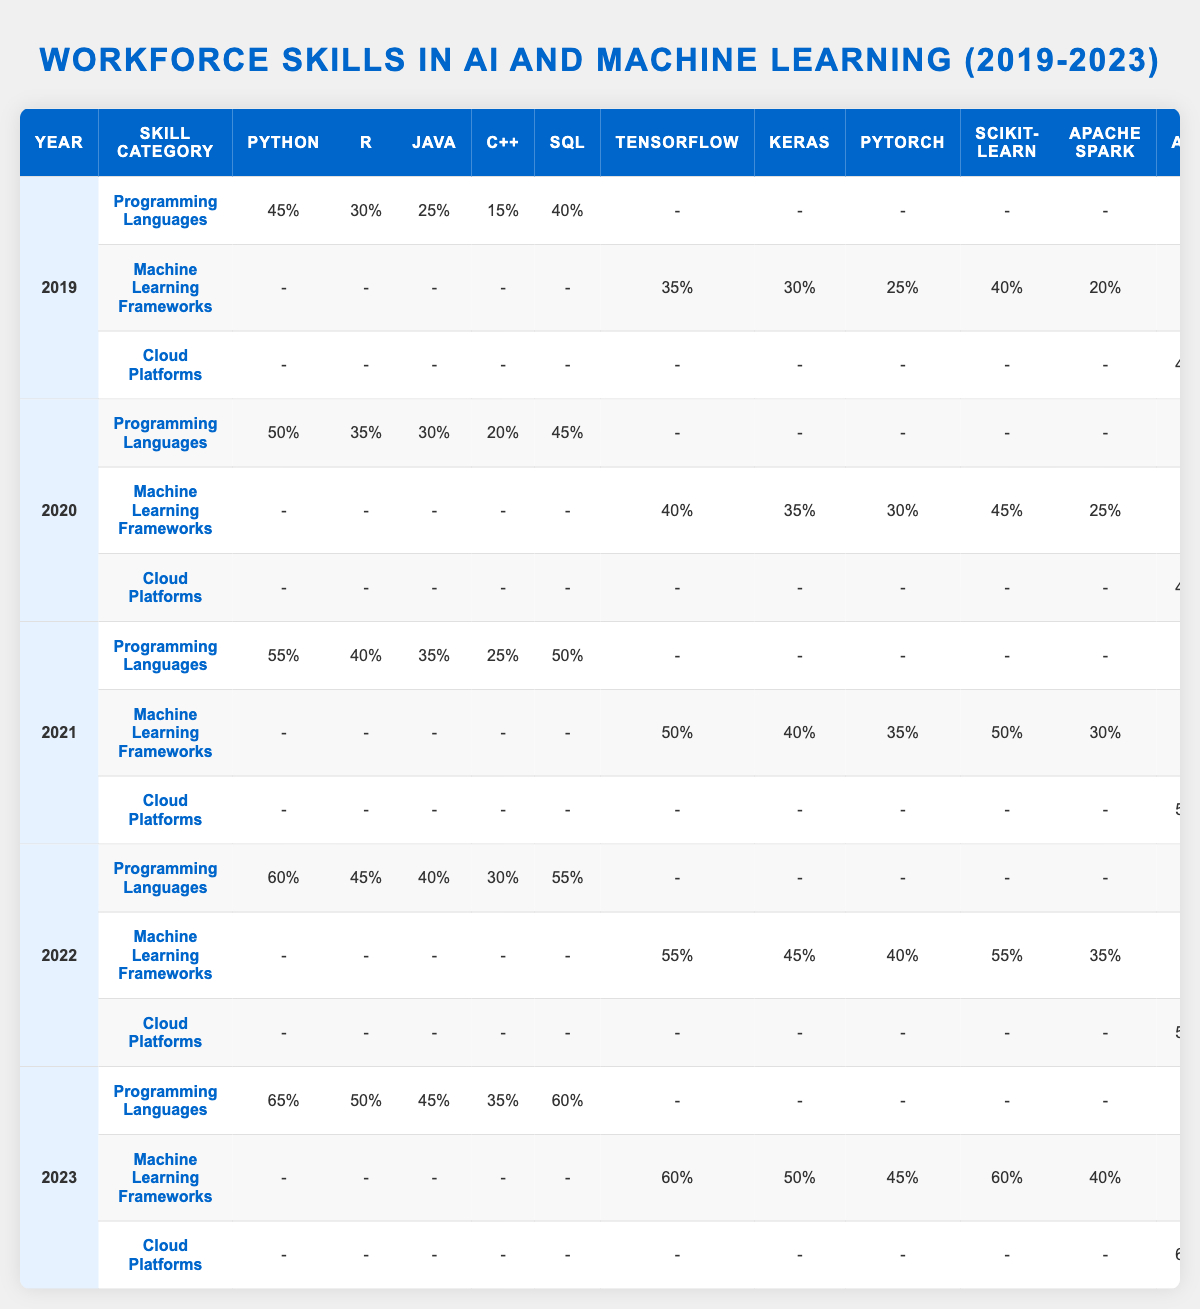What percentage of workforce skills in programming languages was attributed to Python in 2022? In 2022, the value for Python under the Programming Languages skill category is 60%.
Answer: 60% Which machine learning framework had the highest percentage in 2021? In 2021, TensorFlow and Scikit-learn both had the highest percentage of 50%, but TensorFlow is mentioned first in the data.
Answer: TensorFlow (50%) What was the increase in the percentage of AWS skills from 2019 to 2023? In 2019, the percentage for AWS was 40%, and in 2023, it was 60%. The increase is 60% - 40% = 20%.
Answer: 20% Which skill category saw the most significant growth in average percentage across the years from 2019 to 2023? Calculating the average for each skill category: Programming Languages (60%), Machine Learning Frameworks (48%), and Cloud Platforms (50%). Programming Languages has the highest average increase of 20% from 45% to 65%.
Answer: Programming Languages Did the percentage of SQL skills ever drop during the years 2019 to 2023? The SQL percentage was 40% in 2019, 45% in 2020, 50% in 2021, 55% in 2022, and 60% in 2023, indicating it consistently increased each year.
Answer: No What is the percentage increase for Keras from 2020 to 2023? Keras had a percentage of 35% in 2020 and increased to 50% in 2023. The increase is 50% - 35% = 15%.
Answer: 15% Compare the total percentage of Cloud Platforms' skills in 2022 versus 2023. In 2022, the total was (55% + 45% + 40% + 30%) = 170%, while in 2023, it was (60% + 50% + 45% + 35%) = 190%. Thus, Cloud Platforms saw an increase of 20%.
Answer: 20% Which programming language had the least percentage overall in 2019? In 2019, the least percentage for programming languages was C++, which had 15%.
Answer: C++ Was there any year during the period (2019-2023) where the percentage for Java skills was lower than 30%? The percentage for Java in 2019 was 25%, which is lower than 30%.
Answer: Yes Calculate the average percentage of all skills under Machine Learning Frameworks for 2021. The percentages in 2021 were TensorFlow (50%), Keras (40%), PyTorch (35%), Scikit-learn (50%), and Apache Spark (30%). The total is 50 + 40 + 35 + 50 + 30 = 205. The average is 205 / 5 = 41.
Answer: 41 